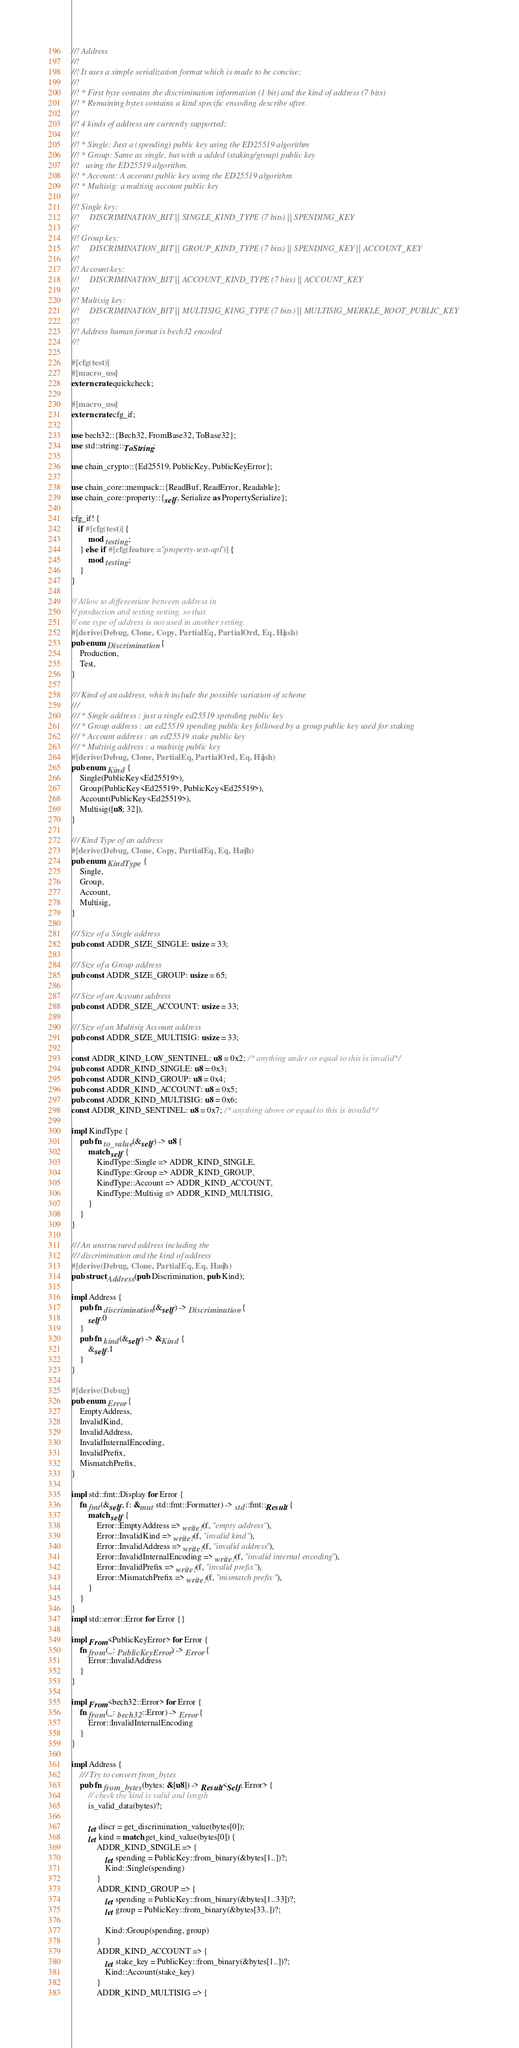Convert code to text. <code><loc_0><loc_0><loc_500><loc_500><_Rust_>//! Address
//!
//! It uses a simple serialization format which is made to be concise:
//!
//! * First byte contains the discrimination information (1 bit) and the kind of address (7 bits)
//! * Remaining bytes contains a kind specific encoding describe after.
//!
//! 4 kinds of address are currently supported:
//!
//! * Single: Just a (spending) public key using the ED25519 algorithm
//! * Group: Same as single, but with a added (staking/group) public key
//!   using the ED25519 algorithm.
//! * Account: A account public key using the ED25519 algorithm
//! * Multisig: a multisig account public key
//!
//! Single key:
//!     DISCRIMINATION_BIT || SINGLE_KIND_TYPE (7 bits) || SPENDING_KEY
//!
//! Group key:
//!     DISCRIMINATION_BIT || GROUP_KIND_TYPE (7 bits) || SPENDING_KEY || ACCOUNT_KEY
//!
//! Account key:
//!     DISCRIMINATION_BIT || ACCOUNT_KIND_TYPE (7 bits) || ACCOUNT_KEY
//!
//! Multisig key:
//!     DISCRIMINATION_BIT || MULTISIG_KING_TYPE (7 bits) || MULTISIG_MERKLE_ROOT_PUBLIC_KEY
//!
//! Address human format is bech32 encoded
//!

#[cfg(test)]
#[macro_use]
extern crate quickcheck;

#[macro_use]
extern crate cfg_if;

use bech32::{Bech32, FromBase32, ToBase32};
use std::string::ToString;

use chain_crypto::{Ed25519, PublicKey, PublicKeyError};

use chain_core::mempack::{ReadBuf, ReadError, Readable};
use chain_core::property::{self, Serialize as PropertySerialize};

cfg_if! {
   if #[cfg(test)] {
        mod testing;
    } else if #[cfg(feature = "property-test-api")] {
        mod testing;
    }
}

// Allow to differentiate between address in
// production and testing setting, so that
// one type of address is not used in another setting.
#[derive(Debug, Clone, Copy, PartialEq, PartialOrd, Eq, Hash)]
pub enum Discrimination {
    Production,
    Test,
}

/// Kind of an address, which include the possible variation of scheme
///
/// * Single address : just a single ed25519 spending public key
/// * Group address : an ed25519 spending public key followed by a group public key used for staking
/// * Account address : an ed25519 stake public key
/// * Multisig address : a multisig public key
#[derive(Debug, Clone, PartialEq, PartialOrd, Eq, Hash)]
pub enum Kind {
    Single(PublicKey<Ed25519>),
    Group(PublicKey<Ed25519>, PublicKey<Ed25519>),
    Account(PublicKey<Ed25519>),
    Multisig([u8; 32]),
}

/// Kind Type of an address
#[derive(Debug, Clone, Copy, PartialEq, Eq, Hash)]
pub enum KindType {
    Single,
    Group,
    Account,
    Multisig,
}

/// Size of a Single address
pub const ADDR_SIZE_SINGLE: usize = 33;

/// Size of a Group address
pub const ADDR_SIZE_GROUP: usize = 65;

/// Size of an Account address
pub const ADDR_SIZE_ACCOUNT: usize = 33;

/// Size of an Multisig Account address
pub const ADDR_SIZE_MULTISIG: usize = 33;

const ADDR_KIND_LOW_SENTINEL: u8 = 0x2; /* anything under or equal to this is invalid */
pub const ADDR_KIND_SINGLE: u8 = 0x3;
pub const ADDR_KIND_GROUP: u8 = 0x4;
pub const ADDR_KIND_ACCOUNT: u8 = 0x5;
pub const ADDR_KIND_MULTISIG: u8 = 0x6;
const ADDR_KIND_SENTINEL: u8 = 0x7; /* anything above or equal to this is invalid */

impl KindType {
    pub fn to_value(&self) -> u8 {
        match self {
            KindType::Single => ADDR_KIND_SINGLE,
            KindType::Group => ADDR_KIND_GROUP,
            KindType::Account => ADDR_KIND_ACCOUNT,
            KindType::Multisig => ADDR_KIND_MULTISIG,
        }
    }
}

/// An unstructured address including the
/// discrimination and the kind of address
#[derive(Debug, Clone, PartialEq, Eq, Hash)]
pub struct Address(pub Discrimination, pub Kind);

impl Address {
    pub fn discrimination(&self) -> Discrimination {
        self.0
    }
    pub fn kind(&self) -> &Kind {
        &self.1
    }
}

#[derive(Debug)]
pub enum Error {
    EmptyAddress,
    InvalidKind,
    InvalidAddress,
    InvalidInternalEncoding,
    InvalidPrefix,
    MismatchPrefix,
}

impl std::fmt::Display for Error {
    fn fmt(&self, f: &mut std::fmt::Formatter) -> std::fmt::Result {
        match self {
            Error::EmptyAddress => write!(f, "empty address"),
            Error::InvalidKind => write!(f, "invalid kind"),
            Error::InvalidAddress => write!(f, "invalid address"),
            Error::InvalidInternalEncoding => write!(f, "invalid internal encoding"),
            Error::InvalidPrefix => write!(f, "invalid prefix"),
            Error::MismatchPrefix => write!(f, "mismatch prefix"),
        }
    }
}
impl std::error::Error for Error {}

impl From<PublicKeyError> for Error {
    fn from(_: PublicKeyError) -> Error {
        Error::InvalidAddress
    }
}

impl From<bech32::Error> for Error {
    fn from(_: bech32::Error) -> Error {
        Error::InvalidInternalEncoding
    }
}

impl Address {
    /// Try to convert from_bytes
    pub fn from_bytes(bytes: &[u8]) -> Result<Self, Error> {
        // check the kind is valid and length
        is_valid_data(bytes)?;

        let discr = get_discrimination_value(bytes[0]);
        let kind = match get_kind_value(bytes[0]) {
            ADDR_KIND_SINGLE => {
                let spending = PublicKey::from_binary(&bytes[1..])?;
                Kind::Single(spending)
            }
            ADDR_KIND_GROUP => {
                let spending = PublicKey::from_binary(&bytes[1..33])?;
                let group = PublicKey::from_binary(&bytes[33..])?;

                Kind::Group(spending, group)
            }
            ADDR_KIND_ACCOUNT => {
                let stake_key = PublicKey::from_binary(&bytes[1..])?;
                Kind::Account(stake_key)
            }
            ADDR_KIND_MULTISIG => {</code> 